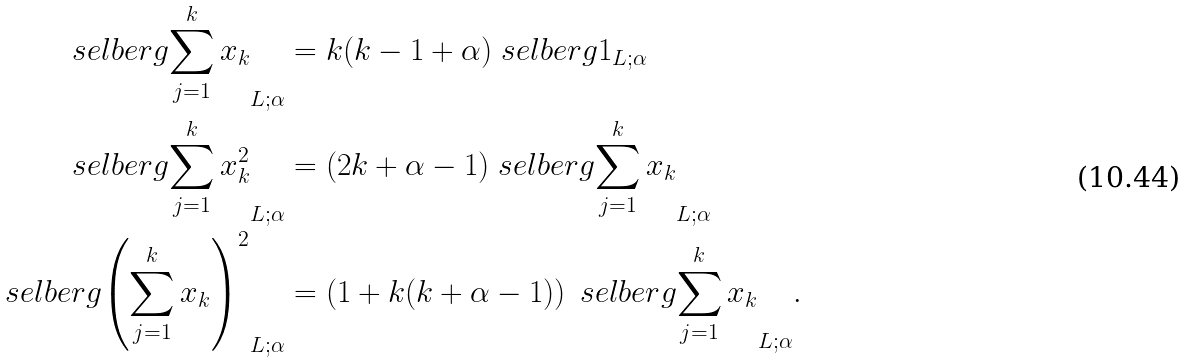Convert formula to latex. <formula><loc_0><loc_0><loc_500><loc_500>\ s e l b e r g { \sum _ { j = 1 } ^ { k } x _ { k } } _ { L ; \alpha } & = k ( k - 1 + \alpha ) \ s e l b e r g { 1 } _ { L ; \alpha } \\ \ s e l b e r g { \sum _ { j = 1 } ^ { k } x _ { k } ^ { 2 } } _ { L ; \alpha } & = ( 2 k + \alpha - 1 ) \ s e l b e r g { \sum _ { j = 1 } ^ { k } x _ { k } } _ { L ; \alpha } \\ \ s e l b e r g { \left ( \sum _ { j = 1 } ^ { k } x _ { k } \right ) ^ { 2 } } _ { L ; \alpha } & = \left ( 1 + k ( k + \alpha - 1 ) \right ) \ s e l b e r g { \sum _ { j = 1 } ^ { k } x _ { k } } _ { L ; \alpha } .</formula> 